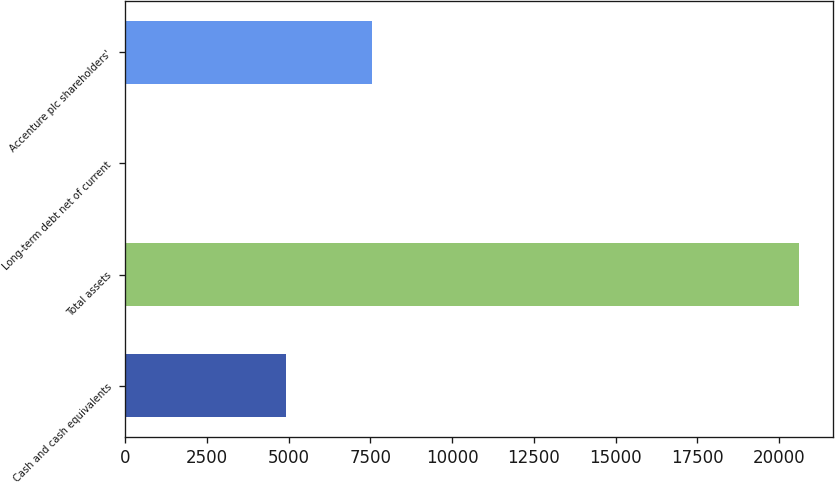<chart> <loc_0><loc_0><loc_500><loc_500><bar_chart><fcel>Cash and cash equivalents<fcel>Total assets<fcel>Long-term debt net of current<fcel>Accenture plc shareholders'<nl><fcel>4906<fcel>20609<fcel>24<fcel>7555<nl></chart> 